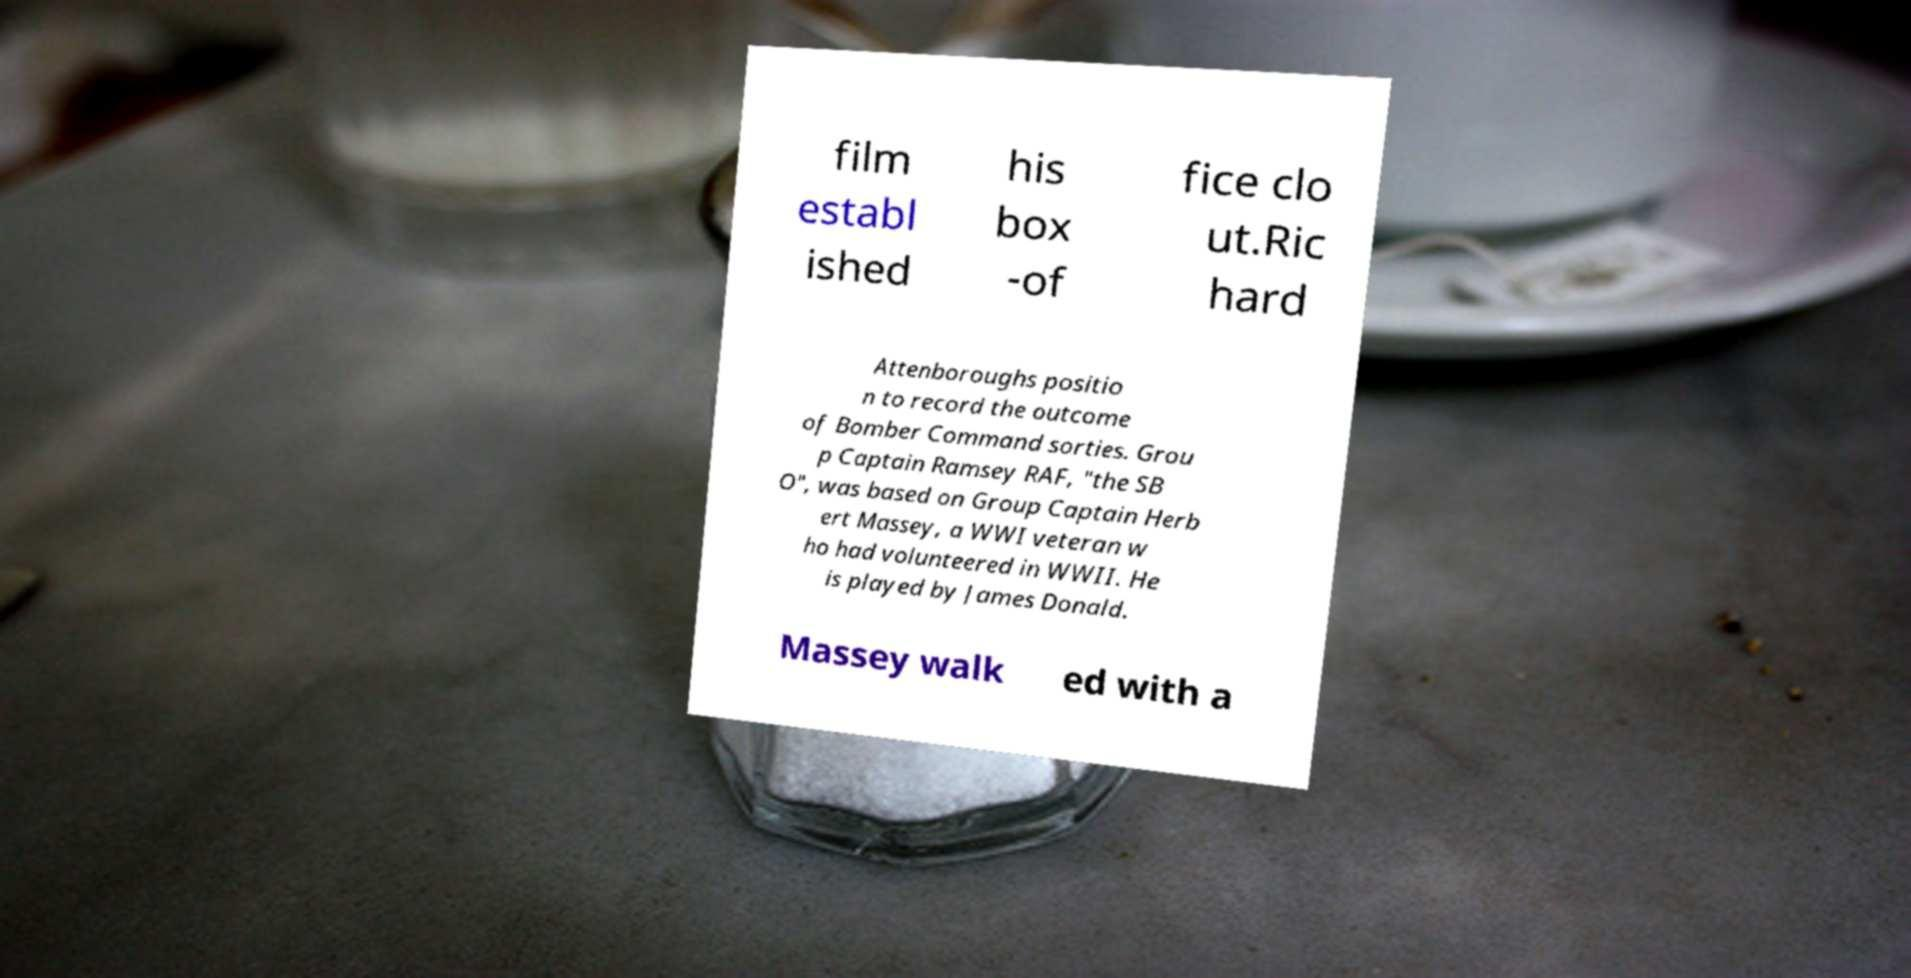There's text embedded in this image that I need extracted. Can you transcribe it verbatim? film establ ished his box -of fice clo ut.Ric hard Attenboroughs positio n to record the outcome of Bomber Command sorties. Grou p Captain Ramsey RAF, "the SB O", was based on Group Captain Herb ert Massey, a WWI veteran w ho had volunteered in WWII. He is played by James Donald. Massey walk ed with a 